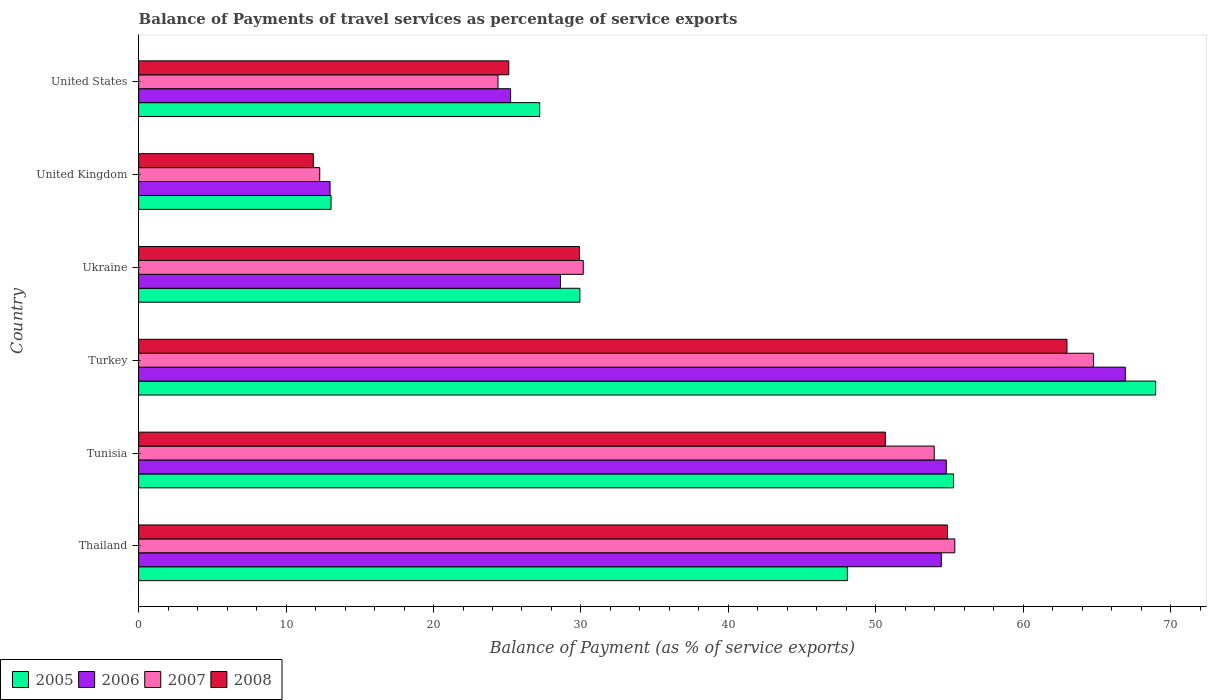How many different coloured bars are there?
Your response must be concise. 4. How many groups of bars are there?
Make the answer very short. 6. Are the number of bars per tick equal to the number of legend labels?
Your response must be concise. Yes. Are the number of bars on each tick of the Y-axis equal?
Give a very brief answer. Yes. How many bars are there on the 2nd tick from the top?
Ensure brevity in your answer.  4. How many bars are there on the 5th tick from the bottom?
Keep it short and to the point. 4. What is the balance of payments of travel services in 2005 in Turkey?
Offer a very short reply. 68.98. Across all countries, what is the maximum balance of payments of travel services in 2006?
Ensure brevity in your answer.  66.92. Across all countries, what is the minimum balance of payments of travel services in 2007?
Keep it short and to the point. 12.28. What is the total balance of payments of travel services in 2008 in the graph?
Offer a very short reply. 235.32. What is the difference between the balance of payments of travel services in 2008 in United Kingdom and that in United States?
Make the answer very short. -13.26. What is the difference between the balance of payments of travel services in 2006 in United States and the balance of payments of travel services in 2005 in United Kingdom?
Your response must be concise. 12.18. What is the average balance of payments of travel services in 2007 per country?
Ensure brevity in your answer.  40.15. What is the difference between the balance of payments of travel services in 2007 and balance of payments of travel services in 2005 in United States?
Your answer should be compact. -2.83. In how many countries, is the balance of payments of travel services in 2006 greater than 20 %?
Offer a terse response. 5. What is the ratio of the balance of payments of travel services in 2008 in Thailand to that in United States?
Your answer should be compact. 2.19. What is the difference between the highest and the second highest balance of payments of travel services in 2005?
Ensure brevity in your answer.  13.71. What is the difference between the highest and the lowest balance of payments of travel services in 2008?
Your answer should be compact. 51.11. In how many countries, is the balance of payments of travel services in 2007 greater than the average balance of payments of travel services in 2007 taken over all countries?
Provide a succinct answer. 3. Is it the case that in every country, the sum of the balance of payments of travel services in 2007 and balance of payments of travel services in 2008 is greater than the sum of balance of payments of travel services in 2005 and balance of payments of travel services in 2006?
Your response must be concise. No. What does the 1st bar from the bottom in Turkey represents?
Offer a very short reply. 2005. How many countries are there in the graph?
Your answer should be compact. 6. Are the values on the major ticks of X-axis written in scientific E-notation?
Give a very brief answer. No. Does the graph contain grids?
Your response must be concise. No. How many legend labels are there?
Provide a short and direct response. 4. How are the legend labels stacked?
Keep it short and to the point. Horizontal. What is the title of the graph?
Ensure brevity in your answer.  Balance of Payments of travel services as percentage of service exports. What is the label or title of the X-axis?
Give a very brief answer. Balance of Payment (as % of service exports). What is the Balance of Payment (as % of service exports) in 2005 in Thailand?
Ensure brevity in your answer.  48.07. What is the Balance of Payment (as % of service exports) in 2006 in Thailand?
Provide a short and direct response. 54.44. What is the Balance of Payment (as % of service exports) of 2007 in Thailand?
Give a very brief answer. 55.36. What is the Balance of Payment (as % of service exports) of 2008 in Thailand?
Provide a succinct answer. 54.86. What is the Balance of Payment (as % of service exports) of 2005 in Tunisia?
Offer a terse response. 55.27. What is the Balance of Payment (as % of service exports) in 2006 in Tunisia?
Provide a short and direct response. 54.78. What is the Balance of Payment (as % of service exports) of 2007 in Tunisia?
Give a very brief answer. 53.96. What is the Balance of Payment (as % of service exports) of 2008 in Tunisia?
Keep it short and to the point. 50.65. What is the Balance of Payment (as % of service exports) of 2005 in Turkey?
Keep it short and to the point. 68.98. What is the Balance of Payment (as % of service exports) in 2006 in Turkey?
Your answer should be very brief. 66.92. What is the Balance of Payment (as % of service exports) of 2007 in Turkey?
Offer a terse response. 64.76. What is the Balance of Payment (as % of service exports) of 2008 in Turkey?
Keep it short and to the point. 62.96. What is the Balance of Payment (as % of service exports) in 2005 in Ukraine?
Offer a very short reply. 29.93. What is the Balance of Payment (as % of service exports) in 2006 in Ukraine?
Make the answer very short. 28.61. What is the Balance of Payment (as % of service exports) of 2007 in Ukraine?
Give a very brief answer. 30.16. What is the Balance of Payment (as % of service exports) of 2008 in Ukraine?
Your answer should be compact. 29.9. What is the Balance of Payment (as % of service exports) of 2005 in United Kingdom?
Offer a terse response. 13.05. What is the Balance of Payment (as % of service exports) of 2006 in United Kingdom?
Ensure brevity in your answer.  12.98. What is the Balance of Payment (as % of service exports) of 2007 in United Kingdom?
Your response must be concise. 12.28. What is the Balance of Payment (as % of service exports) in 2008 in United Kingdom?
Provide a succinct answer. 11.85. What is the Balance of Payment (as % of service exports) of 2005 in United States?
Offer a very short reply. 27.2. What is the Balance of Payment (as % of service exports) in 2006 in United States?
Keep it short and to the point. 25.23. What is the Balance of Payment (as % of service exports) of 2007 in United States?
Your response must be concise. 24.37. What is the Balance of Payment (as % of service exports) in 2008 in United States?
Ensure brevity in your answer.  25.11. Across all countries, what is the maximum Balance of Payment (as % of service exports) of 2005?
Make the answer very short. 68.98. Across all countries, what is the maximum Balance of Payment (as % of service exports) in 2006?
Make the answer very short. 66.92. Across all countries, what is the maximum Balance of Payment (as % of service exports) of 2007?
Make the answer very short. 64.76. Across all countries, what is the maximum Balance of Payment (as % of service exports) in 2008?
Give a very brief answer. 62.96. Across all countries, what is the minimum Balance of Payment (as % of service exports) in 2005?
Offer a very short reply. 13.05. Across all countries, what is the minimum Balance of Payment (as % of service exports) in 2006?
Ensure brevity in your answer.  12.98. Across all countries, what is the minimum Balance of Payment (as % of service exports) in 2007?
Your response must be concise. 12.28. Across all countries, what is the minimum Balance of Payment (as % of service exports) in 2008?
Your answer should be very brief. 11.85. What is the total Balance of Payment (as % of service exports) of 2005 in the graph?
Provide a succinct answer. 242.5. What is the total Balance of Payment (as % of service exports) of 2006 in the graph?
Offer a very short reply. 242.96. What is the total Balance of Payment (as % of service exports) in 2007 in the graph?
Your answer should be very brief. 240.89. What is the total Balance of Payment (as % of service exports) in 2008 in the graph?
Provide a succinct answer. 235.32. What is the difference between the Balance of Payment (as % of service exports) in 2005 in Thailand and that in Tunisia?
Provide a succinct answer. -7.2. What is the difference between the Balance of Payment (as % of service exports) of 2006 in Thailand and that in Tunisia?
Offer a terse response. -0.34. What is the difference between the Balance of Payment (as % of service exports) of 2007 in Thailand and that in Tunisia?
Provide a succinct answer. 1.39. What is the difference between the Balance of Payment (as % of service exports) in 2008 in Thailand and that in Tunisia?
Ensure brevity in your answer.  4.21. What is the difference between the Balance of Payment (as % of service exports) in 2005 in Thailand and that in Turkey?
Offer a terse response. -20.91. What is the difference between the Balance of Payment (as % of service exports) of 2006 in Thailand and that in Turkey?
Provide a succinct answer. -12.48. What is the difference between the Balance of Payment (as % of service exports) in 2007 in Thailand and that in Turkey?
Provide a short and direct response. -9.4. What is the difference between the Balance of Payment (as % of service exports) of 2008 in Thailand and that in Turkey?
Offer a terse response. -8.1. What is the difference between the Balance of Payment (as % of service exports) of 2005 in Thailand and that in Ukraine?
Your answer should be very brief. 18.14. What is the difference between the Balance of Payment (as % of service exports) of 2006 in Thailand and that in Ukraine?
Offer a terse response. 25.83. What is the difference between the Balance of Payment (as % of service exports) in 2007 in Thailand and that in Ukraine?
Your answer should be compact. 25.2. What is the difference between the Balance of Payment (as % of service exports) of 2008 in Thailand and that in Ukraine?
Make the answer very short. 24.96. What is the difference between the Balance of Payment (as % of service exports) of 2005 in Thailand and that in United Kingdom?
Give a very brief answer. 35.02. What is the difference between the Balance of Payment (as % of service exports) in 2006 in Thailand and that in United Kingdom?
Your answer should be compact. 41.46. What is the difference between the Balance of Payment (as % of service exports) of 2007 in Thailand and that in United Kingdom?
Provide a succinct answer. 43.07. What is the difference between the Balance of Payment (as % of service exports) of 2008 in Thailand and that in United Kingdom?
Keep it short and to the point. 43.01. What is the difference between the Balance of Payment (as % of service exports) of 2005 in Thailand and that in United States?
Provide a short and direct response. 20.87. What is the difference between the Balance of Payment (as % of service exports) of 2006 in Thailand and that in United States?
Provide a short and direct response. 29.21. What is the difference between the Balance of Payment (as % of service exports) of 2007 in Thailand and that in United States?
Ensure brevity in your answer.  30.98. What is the difference between the Balance of Payment (as % of service exports) of 2008 in Thailand and that in United States?
Offer a terse response. 29.75. What is the difference between the Balance of Payment (as % of service exports) in 2005 in Tunisia and that in Turkey?
Offer a terse response. -13.71. What is the difference between the Balance of Payment (as % of service exports) of 2006 in Tunisia and that in Turkey?
Ensure brevity in your answer.  -12.14. What is the difference between the Balance of Payment (as % of service exports) of 2007 in Tunisia and that in Turkey?
Offer a very short reply. -10.8. What is the difference between the Balance of Payment (as % of service exports) of 2008 in Tunisia and that in Turkey?
Keep it short and to the point. -12.32. What is the difference between the Balance of Payment (as % of service exports) in 2005 in Tunisia and that in Ukraine?
Provide a succinct answer. 25.34. What is the difference between the Balance of Payment (as % of service exports) of 2006 in Tunisia and that in Ukraine?
Provide a short and direct response. 26.17. What is the difference between the Balance of Payment (as % of service exports) of 2007 in Tunisia and that in Ukraine?
Your answer should be compact. 23.8. What is the difference between the Balance of Payment (as % of service exports) in 2008 in Tunisia and that in Ukraine?
Provide a short and direct response. 20.75. What is the difference between the Balance of Payment (as % of service exports) in 2005 in Tunisia and that in United Kingdom?
Provide a succinct answer. 42.22. What is the difference between the Balance of Payment (as % of service exports) in 2006 in Tunisia and that in United Kingdom?
Provide a succinct answer. 41.79. What is the difference between the Balance of Payment (as % of service exports) of 2007 in Tunisia and that in United Kingdom?
Your answer should be very brief. 41.68. What is the difference between the Balance of Payment (as % of service exports) in 2008 in Tunisia and that in United Kingdom?
Offer a very short reply. 38.8. What is the difference between the Balance of Payment (as % of service exports) of 2005 in Tunisia and that in United States?
Your answer should be compact. 28.07. What is the difference between the Balance of Payment (as % of service exports) in 2006 in Tunisia and that in United States?
Your answer should be very brief. 29.55. What is the difference between the Balance of Payment (as % of service exports) in 2007 in Tunisia and that in United States?
Give a very brief answer. 29.59. What is the difference between the Balance of Payment (as % of service exports) in 2008 in Tunisia and that in United States?
Make the answer very short. 25.54. What is the difference between the Balance of Payment (as % of service exports) in 2005 in Turkey and that in Ukraine?
Provide a short and direct response. 39.05. What is the difference between the Balance of Payment (as % of service exports) in 2006 in Turkey and that in Ukraine?
Make the answer very short. 38.31. What is the difference between the Balance of Payment (as % of service exports) in 2007 in Turkey and that in Ukraine?
Your answer should be very brief. 34.6. What is the difference between the Balance of Payment (as % of service exports) in 2008 in Turkey and that in Ukraine?
Your answer should be very brief. 33.06. What is the difference between the Balance of Payment (as % of service exports) in 2005 in Turkey and that in United Kingdom?
Make the answer very short. 55.93. What is the difference between the Balance of Payment (as % of service exports) in 2006 in Turkey and that in United Kingdom?
Offer a terse response. 53.93. What is the difference between the Balance of Payment (as % of service exports) in 2007 in Turkey and that in United Kingdom?
Give a very brief answer. 52.48. What is the difference between the Balance of Payment (as % of service exports) in 2008 in Turkey and that in United Kingdom?
Offer a terse response. 51.11. What is the difference between the Balance of Payment (as % of service exports) of 2005 in Turkey and that in United States?
Make the answer very short. 41.77. What is the difference between the Balance of Payment (as % of service exports) in 2006 in Turkey and that in United States?
Ensure brevity in your answer.  41.69. What is the difference between the Balance of Payment (as % of service exports) in 2007 in Turkey and that in United States?
Provide a succinct answer. 40.38. What is the difference between the Balance of Payment (as % of service exports) in 2008 in Turkey and that in United States?
Provide a short and direct response. 37.86. What is the difference between the Balance of Payment (as % of service exports) of 2005 in Ukraine and that in United Kingdom?
Your answer should be very brief. 16.88. What is the difference between the Balance of Payment (as % of service exports) in 2006 in Ukraine and that in United Kingdom?
Provide a short and direct response. 15.63. What is the difference between the Balance of Payment (as % of service exports) of 2007 in Ukraine and that in United Kingdom?
Your answer should be very brief. 17.87. What is the difference between the Balance of Payment (as % of service exports) in 2008 in Ukraine and that in United Kingdom?
Your response must be concise. 18.05. What is the difference between the Balance of Payment (as % of service exports) of 2005 in Ukraine and that in United States?
Offer a terse response. 2.72. What is the difference between the Balance of Payment (as % of service exports) of 2006 in Ukraine and that in United States?
Make the answer very short. 3.38. What is the difference between the Balance of Payment (as % of service exports) in 2007 in Ukraine and that in United States?
Provide a succinct answer. 5.78. What is the difference between the Balance of Payment (as % of service exports) in 2008 in Ukraine and that in United States?
Provide a succinct answer. 4.79. What is the difference between the Balance of Payment (as % of service exports) of 2005 in United Kingdom and that in United States?
Give a very brief answer. -14.15. What is the difference between the Balance of Payment (as % of service exports) of 2006 in United Kingdom and that in United States?
Your answer should be compact. -12.24. What is the difference between the Balance of Payment (as % of service exports) in 2007 in United Kingdom and that in United States?
Make the answer very short. -12.09. What is the difference between the Balance of Payment (as % of service exports) of 2008 in United Kingdom and that in United States?
Provide a short and direct response. -13.26. What is the difference between the Balance of Payment (as % of service exports) in 2005 in Thailand and the Balance of Payment (as % of service exports) in 2006 in Tunisia?
Provide a succinct answer. -6.71. What is the difference between the Balance of Payment (as % of service exports) in 2005 in Thailand and the Balance of Payment (as % of service exports) in 2007 in Tunisia?
Provide a succinct answer. -5.89. What is the difference between the Balance of Payment (as % of service exports) in 2005 in Thailand and the Balance of Payment (as % of service exports) in 2008 in Tunisia?
Keep it short and to the point. -2.58. What is the difference between the Balance of Payment (as % of service exports) of 2006 in Thailand and the Balance of Payment (as % of service exports) of 2007 in Tunisia?
Keep it short and to the point. 0.48. What is the difference between the Balance of Payment (as % of service exports) in 2006 in Thailand and the Balance of Payment (as % of service exports) in 2008 in Tunisia?
Provide a succinct answer. 3.8. What is the difference between the Balance of Payment (as % of service exports) of 2007 in Thailand and the Balance of Payment (as % of service exports) of 2008 in Tunisia?
Keep it short and to the point. 4.71. What is the difference between the Balance of Payment (as % of service exports) of 2005 in Thailand and the Balance of Payment (as % of service exports) of 2006 in Turkey?
Keep it short and to the point. -18.85. What is the difference between the Balance of Payment (as % of service exports) in 2005 in Thailand and the Balance of Payment (as % of service exports) in 2007 in Turkey?
Your answer should be compact. -16.69. What is the difference between the Balance of Payment (as % of service exports) in 2005 in Thailand and the Balance of Payment (as % of service exports) in 2008 in Turkey?
Make the answer very short. -14.89. What is the difference between the Balance of Payment (as % of service exports) of 2006 in Thailand and the Balance of Payment (as % of service exports) of 2007 in Turkey?
Ensure brevity in your answer.  -10.32. What is the difference between the Balance of Payment (as % of service exports) of 2006 in Thailand and the Balance of Payment (as % of service exports) of 2008 in Turkey?
Offer a terse response. -8.52. What is the difference between the Balance of Payment (as % of service exports) in 2007 in Thailand and the Balance of Payment (as % of service exports) in 2008 in Turkey?
Give a very brief answer. -7.61. What is the difference between the Balance of Payment (as % of service exports) in 2005 in Thailand and the Balance of Payment (as % of service exports) in 2006 in Ukraine?
Your response must be concise. 19.46. What is the difference between the Balance of Payment (as % of service exports) in 2005 in Thailand and the Balance of Payment (as % of service exports) in 2007 in Ukraine?
Offer a very short reply. 17.91. What is the difference between the Balance of Payment (as % of service exports) of 2005 in Thailand and the Balance of Payment (as % of service exports) of 2008 in Ukraine?
Offer a terse response. 18.17. What is the difference between the Balance of Payment (as % of service exports) of 2006 in Thailand and the Balance of Payment (as % of service exports) of 2007 in Ukraine?
Ensure brevity in your answer.  24.29. What is the difference between the Balance of Payment (as % of service exports) of 2006 in Thailand and the Balance of Payment (as % of service exports) of 2008 in Ukraine?
Provide a short and direct response. 24.54. What is the difference between the Balance of Payment (as % of service exports) in 2007 in Thailand and the Balance of Payment (as % of service exports) in 2008 in Ukraine?
Offer a very short reply. 25.46. What is the difference between the Balance of Payment (as % of service exports) of 2005 in Thailand and the Balance of Payment (as % of service exports) of 2006 in United Kingdom?
Provide a short and direct response. 35.08. What is the difference between the Balance of Payment (as % of service exports) of 2005 in Thailand and the Balance of Payment (as % of service exports) of 2007 in United Kingdom?
Your response must be concise. 35.79. What is the difference between the Balance of Payment (as % of service exports) of 2005 in Thailand and the Balance of Payment (as % of service exports) of 2008 in United Kingdom?
Give a very brief answer. 36.22. What is the difference between the Balance of Payment (as % of service exports) in 2006 in Thailand and the Balance of Payment (as % of service exports) in 2007 in United Kingdom?
Your response must be concise. 42.16. What is the difference between the Balance of Payment (as % of service exports) in 2006 in Thailand and the Balance of Payment (as % of service exports) in 2008 in United Kingdom?
Ensure brevity in your answer.  42.59. What is the difference between the Balance of Payment (as % of service exports) in 2007 in Thailand and the Balance of Payment (as % of service exports) in 2008 in United Kingdom?
Provide a succinct answer. 43.51. What is the difference between the Balance of Payment (as % of service exports) in 2005 in Thailand and the Balance of Payment (as % of service exports) in 2006 in United States?
Provide a succinct answer. 22.84. What is the difference between the Balance of Payment (as % of service exports) of 2005 in Thailand and the Balance of Payment (as % of service exports) of 2007 in United States?
Your answer should be compact. 23.7. What is the difference between the Balance of Payment (as % of service exports) in 2005 in Thailand and the Balance of Payment (as % of service exports) in 2008 in United States?
Provide a succinct answer. 22.96. What is the difference between the Balance of Payment (as % of service exports) of 2006 in Thailand and the Balance of Payment (as % of service exports) of 2007 in United States?
Your answer should be compact. 30.07. What is the difference between the Balance of Payment (as % of service exports) in 2006 in Thailand and the Balance of Payment (as % of service exports) in 2008 in United States?
Give a very brief answer. 29.34. What is the difference between the Balance of Payment (as % of service exports) of 2007 in Thailand and the Balance of Payment (as % of service exports) of 2008 in United States?
Provide a short and direct response. 30.25. What is the difference between the Balance of Payment (as % of service exports) of 2005 in Tunisia and the Balance of Payment (as % of service exports) of 2006 in Turkey?
Provide a succinct answer. -11.65. What is the difference between the Balance of Payment (as % of service exports) of 2005 in Tunisia and the Balance of Payment (as % of service exports) of 2007 in Turkey?
Keep it short and to the point. -9.49. What is the difference between the Balance of Payment (as % of service exports) of 2005 in Tunisia and the Balance of Payment (as % of service exports) of 2008 in Turkey?
Give a very brief answer. -7.69. What is the difference between the Balance of Payment (as % of service exports) in 2006 in Tunisia and the Balance of Payment (as % of service exports) in 2007 in Turkey?
Offer a very short reply. -9.98. What is the difference between the Balance of Payment (as % of service exports) of 2006 in Tunisia and the Balance of Payment (as % of service exports) of 2008 in Turkey?
Give a very brief answer. -8.18. What is the difference between the Balance of Payment (as % of service exports) in 2007 in Tunisia and the Balance of Payment (as % of service exports) in 2008 in Turkey?
Make the answer very short. -9. What is the difference between the Balance of Payment (as % of service exports) of 2005 in Tunisia and the Balance of Payment (as % of service exports) of 2006 in Ukraine?
Provide a short and direct response. 26.66. What is the difference between the Balance of Payment (as % of service exports) in 2005 in Tunisia and the Balance of Payment (as % of service exports) in 2007 in Ukraine?
Ensure brevity in your answer.  25.11. What is the difference between the Balance of Payment (as % of service exports) of 2005 in Tunisia and the Balance of Payment (as % of service exports) of 2008 in Ukraine?
Offer a terse response. 25.37. What is the difference between the Balance of Payment (as % of service exports) of 2006 in Tunisia and the Balance of Payment (as % of service exports) of 2007 in Ukraine?
Your response must be concise. 24.62. What is the difference between the Balance of Payment (as % of service exports) in 2006 in Tunisia and the Balance of Payment (as % of service exports) in 2008 in Ukraine?
Keep it short and to the point. 24.88. What is the difference between the Balance of Payment (as % of service exports) in 2007 in Tunisia and the Balance of Payment (as % of service exports) in 2008 in Ukraine?
Keep it short and to the point. 24.06. What is the difference between the Balance of Payment (as % of service exports) in 2005 in Tunisia and the Balance of Payment (as % of service exports) in 2006 in United Kingdom?
Give a very brief answer. 42.28. What is the difference between the Balance of Payment (as % of service exports) in 2005 in Tunisia and the Balance of Payment (as % of service exports) in 2007 in United Kingdom?
Provide a succinct answer. 42.99. What is the difference between the Balance of Payment (as % of service exports) in 2005 in Tunisia and the Balance of Payment (as % of service exports) in 2008 in United Kingdom?
Make the answer very short. 43.42. What is the difference between the Balance of Payment (as % of service exports) in 2006 in Tunisia and the Balance of Payment (as % of service exports) in 2007 in United Kingdom?
Ensure brevity in your answer.  42.5. What is the difference between the Balance of Payment (as % of service exports) in 2006 in Tunisia and the Balance of Payment (as % of service exports) in 2008 in United Kingdom?
Your response must be concise. 42.93. What is the difference between the Balance of Payment (as % of service exports) of 2007 in Tunisia and the Balance of Payment (as % of service exports) of 2008 in United Kingdom?
Make the answer very short. 42.11. What is the difference between the Balance of Payment (as % of service exports) of 2005 in Tunisia and the Balance of Payment (as % of service exports) of 2006 in United States?
Provide a short and direct response. 30.04. What is the difference between the Balance of Payment (as % of service exports) of 2005 in Tunisia and the Balance of Payment (as % of service exports) of 2007 in United States?
Your answer should be compact. 30.9. What is the difference between the Balance of Payment (as % of service exports) of 2005 in Tunisia and the Balance of Payment (as % of service exports) of 2008 in United States?
Make the answer very short. 30.16. What is the difference between the Balance of Payment (as % of service exports) in 2006 in Tunisia and the Balance of Payment (as % of service exports) in 2007 in United States?
Provide a succinct answer. 30.41. What is the difference between the Balance of Payment (as % of service exports) of 2006 in Tunisia and the Balance of Payment (as % of service exports) of 2008 in United States?
Offer a very short reply. 29.67. What is the difference between the Balance of Payment (as % of service exports) of 2007 in Tunisia and the Balance of Payment (as % of service exports) of 2008 in United States?
Give a very brief answer. 28.86. What is the difference between the Balance of Payment (as % of service exports) of 2005 in Turkey and the Balance of Payment (as % of service exports) of 2006 in Ukraine?
Your response must be concise. 40.37. What is the difference between the Balance of Payment (as % of service exports) in 2005 in Turkey and the Balance of Payment (as % of service exports) in 2007 in Ukraine?
Offer a terse response. 38.82. What is the difference between the Balance of Payment (as % of service exports) of 2005 in Turkey and the Balance of Payment (as % of service exports) of 2008 in Ukraine?
Give a very brief answer. 39.08. What is the difference between the Balance of Payment (as % of service exports) of 2006 in Turkey and the Balance of Payment (as % of service exports) of 2007 in Ukraine?
Ensure brevity in your answer.  36.76. What is the difference between the Balance of Payment (as % of service exports) of 2006 in Turkey and the Balance of Payment (as % of service exports) of 2008 in Ukraine?
Offer a very short reply. 37.02. What is the difference between the Balance of Payment (as % of service exports) of 2007 in Turkey and the Balance of Payment (as % of service exports) of 2008 in Ukraine?
Make the answer very short. 34.86. What is the difference between the Balance of Payment (as % of service exports) of 2005 in Turkey and the Balance of Payment (as % of service exports) of 2006 in United Kingdom?
Make the answer very short. 55.99. What is the difference between the Balance of Payment (as % of service exports) in 2005 in Turkey and the Balance of Payment (as % of service exports) in 2007 in United Kingdom?
Keep it short and to the point. 56.7. What is the difference between the Balance of Payment (as % of service exports) of 2005 in Turkey and the Balance of Payment (as % of service exports) of 2008 in United Kingdom?
Offer a very short reply. 57.13. What is the difference between the Balance of Payment (as % of service exports) in 2006 in Turkey and the Balance of Payment (as % of service exports) in 2007 in United Kingdom?
Your answer should be compact. 54.64. What is the difference between the Balance of Payment (as % of service exports) in 2006 in Turkey and the Balance of Payment (as % of service exports) in 2008 in United Kingdom?
Offer a terse response. 55.07. What is the difference between the Balance of Payment (as % of service exports) of 2007 in Turkey and the Balance of Payment (as % of service exports) of 2008 in United Kingdom?
Your answer should be compact. 52.91. What is the difference between the Balance of Payment (as % of service exports) in 2005 in Turkey and the Balance of Payment (as % of service exports) in 2006 in United States?
Your answer should be very brief. 43.75. What is the difference between the Balance of Payment (as % of service exports) in 2005 in Turkey and the Balance of Payment (as % of service exports) in 2007 in United States?
Offer a very short reply. 44.6. What is the difference between the Balance of Payment (as % of service exports) of 2005 in Turkey and the Balance of Payment (as % of service exports) of 2008 in United States?
Your answer should be very brief. 43.87. What is the difference between the Balance of Payment (as % of service exports) in 2006 in Turkey and the Balance of Payment (as % of service exports) in 2007 in United States?
Keep it short and to the point. 42.55. What is the difference between the Balance of Payment (as % of service exports) of 2006 in Turkey and the Balance of Payment (as % of service exports) of 2008 in United States?
Your response must be concise. 41.81. What is the difference between the Balance of Payment (as % of service exports) in 2007 in Turkey and the Balance of Payment (as % of service exports) in 2008 in United States?
Your response must be concise. 39.65. What is the difference between the Balance of Payment (as % of service exports) of 2005 in Ukraine and the Balance of Payment (as % of service exports) of 2006 in United Kingdom?
Your answer should be compact. 16.94. What is the difference between the Balance of Payment (as % of service exports) in 2005 in Ukraine and the Balance of Payment (as % of service exports) in 2007 in United Kingdom?
Ensure brevity in your answer.  17.64. What is the difference between the Balance of Payment (as % of service exports) of 2005 in Ukraine and the Balance of Payment (as % of service exports) of 2008 in United Kingdom?
Your answer should be compact. 18.08. What is the difference between the Balance of Payment (as % of service exports) of 2006 in Ukraine and the Balance of Payment (as % of service exports) of 2007 in United Kingdom?
Ensure brevity in your answer.  16.33. What is the difference between the Balance of Payment (as % of service exports) of 2006 in Ukraine and the Balance of Payment (as % of service exports) of 2008 in United Kingdom?
Offer a terse response. 16.76. What is the difference between the Balance of Payment (as % of service exports) of 2007 in Ukraine and the Balance of Payment (as % of service exports) of 2008 in United Kingdom?
Your response must be concise. 18.31. What is the difference between the Balance of Payment (as % of service exports) in 2005 in Ukraine and the Balance of Payment (as % of service exports) in 2006 in United States?
Ensure brevity in your answer.  4.7. What is the difference between the Balance of Payment (as % of service exports) in 2005 in Ukraine and the Balance of Payment (as % of service exports) in 2007 in United States?
Offer a terse response. 5.55. What is the difference between the Balance of Payment (as % of service exports) of 2005 in Ukraine and the Balance of Payment (as % of service exports) of 2008 in United States?
Provide a short and direct response. 4.82. What is the difference between the Balance of Payment (as % of service exports) in 2006 in Ukraine and the Balance of Payment (as % of service exports) in 2007 in United States?
Make the answer very short. 4.24. What is the difference between the Balance of Payment (as % of service exports) of 2006 in Ukraine and the Balance of Payment (as % of service exports) of 2008 in United States?
Keep it short and to the point. 3.5. What is the difference between the Balance of Payment (as % of service exports) of 2007 in Ukraine and the Balance of Payment (as % of service exports) of 2008 in United States?
Your response must be concise. 5.05. What is the difference between the Balance of Payment (as % of service exports) of 2005 in United Kingdom and the Balance of Payment (as % of service exports) of 2006 in United States?
Keep it short and to the point. -12.18. What is the difference between the Balance of Payment (as % of service exports) of 2005 in United Kingdom and the Balance of Payment (as % of service exports) of 2007 in United States?
Provide a short and direct response. -11.32. What is the difference between the Balance of Payment (as % of service exports) of 2005 in United Kingdom and the Balance of Payment (as % of service exports) of 2008 in United States?
Your answer should be compact. -12.05. What is the difference between the Balance of Payment (as % of service exports) in 2006 in United Kingdom and the Balance of Payment (as % of service exports) in 2007 in United States?
Provide a succinct answer. -11.39. What is the difference between the Balance of Payment (as % of service exports) of 2006 in United Kingdom and the Balance of Payment (as % of service exports) of 2008 in United States?
Keep it short and to the point. -12.12. What is the difference between the Balance of Payment (as % of service exports) of 2007 in United Kingdom and the Balance of Payment (as % of service exports) of 2008 in United States?
Your response must be concise. -12.82. What is the average Balance of Payment (as % of service exports) in 2005 per country?
Provide a short and direct response. 40.42. What is the average Balance of Payment (as % of service exports) in 2006 per country?
Provide a succinct answer. 40.49. What is the average Balance of Payment (as % of service exports) of 2007 per country?
Your answer should be very brief. 40.15. What is the average Balance of Payment (as % of service exports) in 2008 per country?
Your response must be concise. 39.22. What is the difference between the Balance of Payment (as % of service exports) in 2005 and Balance of Payment (as % of service exports) in 2006 in Thailand?
Your response must be concise. -6.37. What is the difference between the Balance of Payment (as % of service exports) of 2005 and Balance of Payment (as % of service exports) of 2007 in Thailand?
Give a very brief answer. -7.29. What is the difference between the Balance of Payment (as % of service exports) in 2005 and Balance of Payment (as % of service exports) in 2008 in Thailand?
Provide a short and direct response. -6.79. What is the difference between the Balance of Payment (as % of service exports) in 2006 and Balance of Payment (as % of service exports) in 2007 in Thailand?
Keep it short and to the point. -0.91. What is the difference between the Balance of Payment (as % of service exports) of 2006 and Balance of Payment (as % of service exports) of 2008 in Thailand?
Your answer should be very brief. -0.42. What is the difference between the Balance of Payment (as % of service exports) of 2007 and Balance of Payment (as % of service exports) of 2008 in Thailand?
Ensure brevity in your answer.  0.5. What is the difference between the Balance of Payment (as % of service exports) of 2005 and Balance of Payment (as % of service exports) of 2006 in Tunisia?
Provide a short and direct response. 0.49. What is the difference between the Balance of Payment (as % of service exports) in 2005 and Balance of Payment (as % of service exports) in 2007 in Tunisia?
Your answer should be compact. 1.31. What is the difference between the Balance of Payment (as % of service exports) of 2005 and Balance of Payment (as % of service exports) of 2008 in Tunisia?
Give a very brief answer. 4.62. What is the difference between the Balance of Payment (as % of service exports) in 2006 and Balance of Payment (as % of service exports) in 2007 in Tunisia?
Offer a very short reply. 0.82. What is the difference between the Balance of Payment (as % of service exports) of 2006 and Balance of Payment (as % of service exports) of 2008 in Tunisia?
Ensure brevity in your answer.  4.13. What is the difference between the Balance of Payment (as % of service exports) in 2007 and Balance of Payment (as % of service exports) in 2008 in Tunisia?
Offer a very short reply. 3.31. What is the difference between the Balance of Payment (as % of service exports) in 2005 and Balance of Payment (as % of service exports) in 2006 in Turkey?
Offer a very short reply. 2.06. What is the difference between the Balance of Payment (as % of service exports) of 2005 and Balance of Payment (as % of service exports) of 2007 in Turkey?
Your answer should be very brief. 4.22. What is the difference between the Balance of Payment (as % of service exports) in 2005 and Balance of Payment (as % of service exports) in 2008 in Turkey?
Give a very brief answer. 6.01. What is the difference between the Balance of Payment (as % of service exports) in 2006 and Balance of Payment (as % of service exports) in 2007 in Turkey?
Make the answer very short. 2.16. What is the difference between the Balance of Payment (as % of service exports) of 2006 and Balance of Payment (as % of service exports) of 2008 in Turkey?
Your answer should be very brief. 3.96. What is the difference between the Balance of Payment (as % of service exports) in 2007 and Balance of Payment (as % of service exports) in 2008 in Turkey?
Offer a very short reply. 1.79. What is the difference between the Balance of Payment (as % of service exports) in 2005 and Balance of Payment (as % of service exports) in 2006 in Ukraine?
Your answer should be compact. 1.32. What is the difference between the Balance of Payment (as % of service exports) in 2005 and Balance of Payment (as % of service exports) in 2007 in Ukraine?
Offer a terse response. -0.23. What is the difference between the Balance of Payment (as % of service exports) of 2005 and Balance of Payment (as % of service exports) of 2008 in Ukraine?
Give a very brief answer. 0.03. What is the difference between the Balance of Payment (as % of service exports) in 2006 and Balance of Payment (as % of service exports) in 2007 in Ukraine?
Offer a very short reply. -1.55. What is the difference between the Balance of Payment (as % of service exports) of 2006 and Balance of Payment (as % of service exports) of 2008 in Ukraine?
Ensure brevity in your answer.  -1.29. What is the difference between the Balance of Payment (as % of service exports) of 2007 and Balance of Payment (as % of service exports) of 2008 in Ukraine?
Offer a terse response. 0.26. What is the difference between the Balance of Payment (as % of service exports) of 2005 and Balance of Payment (as % of service exports) of 2006 in United Kingdom?
Your answer should be very brief. 0.07. What is the difference between the Balance of Payment (as % of service exports) in 2005 and Balance of Payment (as % of service exports) in 2007 in United Kingdom?
Provide a short and direct response. 0.77. What is the difference between the Balance of Payment (as % of service exports) of 2005 and Balance of Payment (as % of service exports) of 2008 in United Kingdom?
Ensure brevity in your answer.  1.2. What is the difference between the Balance of Payment (as % of service exports) in 2006 and Balance of Payment (as % of service exports) in 2007 in United Kingdom?
Your answer should be very brief. 0.7. What is the difference between the Balance of Payment (as % of service exports) of 2006 and Balance of Payment (as % of service exports) of 2008 in United Kingdom?
Give a very brief answer. 1.14. What is the difference between the Balance of Payment (as % of service exports) in 2007 and Balance of Payment (as % of service exports) in 2008 in United Kingdom?
Your answer should be very brief. 0.43. What is the difference between the Balance of Payment (as % of service exports) in 2005 and Balance of Payment (as % of service exports) in 2006 in United States?
Your answer should be very brief. 1.97. What is the difference between the Balance of Payment (as % of service exports) of 2005 and Balance of Payment (as % of service exports) of 2007 in United States?
Your answer should be compact. 2.83. What is the difference between the Balance of Payment (as % of service exports) in 2005 and Balance of Payment (as % of service exports) in 2008 in United States?
Your answer should be compact. 2.1. What is the difference between the Balance of Payment (as % of service exports) in 2006 and Balance of Payment (as % of service exports) in 2007 in United States?
Keep it short and to the point. 0.86. What is the difference between the Balance of Payment (as % of service exports) of 2006 and Balance of Payment (as % of service exports) of 2008 in United States?
Offer a terse response. 0.12. What is the difference between the Balance of Payment (as % of service exports) in 2007 and Balance of Payment (as % of service exports) in 2008 in United States?
Make the answer very short. -0.73. What is the ratio of the Balance of Payment (as % of service exports) of 2005 in Thailand to that in Tunisia?
Your answer should be very brief. 0.87. What is the ratio of the Balance of Payment (as % of service exports) in 2007 in Thailand to that in Tunisia?
Give a very brief answer. 1.03. What is the ratio of the Balance of Payment (as % of service exports) in 2008 in Thailand to that in Tunisia?
Give a very brief answer. 1.08. What is the ratio of the Balance of Payment (as % of service exports) in 2005 in Thailand to that in Turkey?
Offer a very short reply. 0.7. What is the ratio of the Balance of Payment (as % of service exports) of 2006 in Thailand to that in Turkey?
Offer a terse response. 0.81. What is the ratio of the Balance of Payment (as % of service exports) in 2007 in Thailand to that in Turkey?
Give a very brief answer. 0.85. What is the ratio of the Balance of Payment (as % of service exports) of 2008 in Thailand to that in Turkey?
Make the answer very short. 0.87. What is the ratio of the Balance of Payment (as % of service exports) of 2005 in Thailand to that in Ukraine?
Make the answer very short. 1.61. What is the ratio of the Balance of Payment (as % of service exports) of 2006 in Thailand to that in Ukraine?
Ensure brevity in your answer.  1.9. What is the ratio of the Balance of Payment (as % of service exports) of 2007 in Thailand to that in Ukraine?
Provide a succinct answer. 1.84. What is the ratio of the Balance of Payment (as % of service exports) of 2008 in Thailand to that in Ukraine?
Your response must be concise. 1.83. What is the ratio of the Balance of Payment (as % of service exports) of 2005 in Thailand to that in United Kingdom?
Keep it short and to the point. 3.68. What is the ratio of the Balance of Payment (as % of service exports) of 2006 in Thailand to that in United Kingdom?
Ensure brevity in your answer.  4.19. What is the ratio of the Balance of Payment (as % of service exports) in 2007 in Thailand to that in United Kingdom?
Ensure brevity in your answer.  4.51. What is the ratio of the Balance of Payment (as % of service exports) of 2008 in Thailand to that in United Kingdom?
Keep it short and to the point. 4.63. What is the ratio of the Balance of Payment (as % of service exports) in 2005 in Thailand to that in United States?
Provide a short and direct response. 1.77. What is the ratio of the Balance of Payment (as % of service exports) in 2006 in Thailand to that in United States?
Offer a very short reply. 2.16. What is the ratio of the Balance of Payment (as % of service exports) of 2007 in Thailand to that in United States?
Offer a terse response. 2.27. What is the ratio of the Balance of Payment (as % of service exports) of 2008 in Thailand to that in United States?
Keep it short and to the point. 2.19. What is the ratio of the Balance of Payment (as % of service exports) of 2005 in Tunisia to that in Turkey?
Provide a short and direct response. 0.8. What is the ratio of the Balance of Payment (as % of service exports) of 2006 in Tunisia to that in Turkey?
Provide a short and direct response. 0.82. What is the ratio of the Balance of Payment (as % of service exports) of 2007 in Tunisia to that in Turkey?
Keep it short and to the point. 0.83. What is the ratio of the Balance of Payment (as % of service exports) in 2008 in Tunisia to that in Turkey?
Give a very brief answer. 0.8. What is the ratio of the Balance of Payment (as % of service exports) in 2005 in Tunisia to that in Ukraine?
Your answer should be very brief. 1.85. What is the ratio of the Balance of Payment (as % of service exports) of 2006 in Tunisia to that in Ukraine?
Offer a very short reply. 1.91. What is the ratio of the Balance of Payment (as % of service exports) of 2007 in Tunisia to that in Ukraine?
Provide a succinct answer. 1.79. What is the ratio of the Balance of Payment (as % of service exports) of 2008 in Tunisia to that in Ukraine?
Keep it short and to the point. 1.69. What is the ratio of the Balance of Payment (as % of service exports) of 2005 in Tunisia to that in United Kingdom?
Offer a very short reply. 4.24. What is the ratio of the Balance of Payment (as % of service exports) in 2006 in Tunisia to that in United Kingdom?
Your answer should be very brief. 4.22. What is the ratio of the Balance of Payment (as % of service exports) in 2007 in Tunisia to that in United Kingdom?
Provide a short and direct response. 4.39. What is the ratio of the Balance of Payment (as % of service exports) of 2008 in Tunisia to that in United Kingdom?
Your answer should be compact. 4.27. What is the ratio of the Balance of Payment (as % of service exports) of 2005 in Tunisia to that in United States?
Give a very brief answer. 2.03. What is the ratio of the Balance of Payment (as % of service exports) in 2006 in Tunisia to that in United States?
Ensure brevity in your answer.  2.17. What is the ratio of the Balance of Payment (as % of service exports) in 2007 in Tunisia to that in United States?
Give a very brief answer. 2.21. What is the ratio of the Balance of Payment (as % of service exports) of 2008 in Tunisia to that in United States?
Provide a succinct answer. 2.02. What is the ratio of the Balance of Payment (as % of service exports) of 2005 in Turkey to that in Ukraine?
Keep it short and to the point. 2.3. What is the ratio of the Balance of Payment (as % of service exports) in 2006 in Turkey to that in Ukraine?
Your response must be concise. 2.34. What is the ratio of the Balance of Payment (as % of service exports) of 2007 in Turkey to that in Ukraine?
Your response must be concise. 2.15. What is the ratio of the Balance of Payment (as % of service exports) in 2008 in Turkey to that in Ukraine?
Keep it short and to the point. 2.11. What is the ratio of the Balance of Payment (as % of service exports) of 2005 in Turkey to that in United Kingdom?
Give a very brief answer. 5.29. What is the ratio of the Balance of Payment (as % of service exports) in 2006 in Turkey to that in United Kingdom?
Your response must be concise. 5.15. What is the ratio of the Balance of Payment (as % of service exports) of 2007 in Turkey to that in United Kingdom?
Provide a succinct answer. 5.27. What is the ratio of the Balance of Payment (as % of service exports) of 2008 in Turkey to that in United Kingdom?
Give a very brief answer. 5.31. What is the ratio of the Balance of Payment (as % of service exports) of 2005 in Turkey to that in United States?
Ensure brevity in your answer.  2.54. What is the ratio of the Balance of Payment (as % of service exports) of 2006 in Turkey to that in United States?
Offer a very short reply. 2.65. What is the ratio of the Balance of Payment (as % of service exports) in 2007 in Turkey to that in United States?
Keep it short and to the point. 2.66. What is the ratio of the Balance of Payment (as % of service exports) in 2008 in Turkey to that in United States?
Offer a very short reply. 2.51. What is the ratio of the Balance of Payment (as % of service exports) of 2005 in Ukraine to that in United Kingdom?
Your response must be concise. 2.29. What is the ratio of the Balance of Payment (as % of service exports) of 2006 in Ukraine to that in United Kingdom?
Ensure brevity in your answer.  2.2. What is the ratio of the Balance of Payment (as % of service exports) in 2007 in Ukraine to that in United Kingdom?
Offer a terse response. 2.46. What is the ratio of the Balance of Payment (as % of service exports) in 2008 in Ukraine to that in United Kingdom?
Provide a succinct answer. 2.52. What is the ratio of the Balance of Payment (as % of service exports) of 2005 in Ukraine to that in United States?
Give a very brief answer. 1.1. What is the ratio of the Balance of Payment (as % of service exports) of 2006 in Ukraine to that in United States?
Ensure brevity in your answer.  1.13. What is the ratio of the Balance of Payment (as % of service exports) of 2007 in Ukraine to that in United States?
Give a very brief answer. 1.24. What is the ratio of the Balance of Payment (as % of service exports) of 2008 in Ukraine to that in United States?
Your response must be concise. 1.19. What is the ratio of the Balance of Payment (as % of service exports) of 2005 in United Kingdom to that in United States?
Offer a terse response. 0.48. What is the ratio of the Balance of Payment (as % of service exports) of 2006 in United Kingdom to that in United States?
Offer a terse response. 0.51. What is the ratio of the Balance of Payment (as % of service exports) of 2007 in United Kingdom to that in United States?
Your answer should be very brief. 0.5. What is the ratio of the Balance of Payment (as % of service exports) of 2008 in United Kingdom to that in United States?
Your answer should be compact. 0.47. What is the difference between the highest and the second highest Balance of Payment (as % of service exports) of 2005?
Provide a short and direct response. 13.71. What is the difference between the highest and the second highest Balance of Payment (as % of service exports) in 2006?
Provide a succinct answer. 12.14. What is the difference between the highest and the second highest Balance of Payment (as % of service exports) of 2007?
Make the answer very short. 9.4. What is the difference between the highest and the second highest Balance of Payment (as % of service exports) of 2008?
Offer a terse response. 8.1. What is the difference between the highest and the lowest Balance of Payment (as % of service exports) in 2005?
Provide a succinct answer. 55.93. What is the difference between the highest and the lowest Balance of Payment (as % of service exports) of 2006?
Your response must be concise. 53.93. What is the difference between the highest and the lowest Balance of Payment (as % of service exports) in 2007?
Give a very brief answer. 52.48. What is the difference between the highest and the lowest Balance of Payment (as % of service exports) of 2008?
Keep it short and to the point. 51.11. 